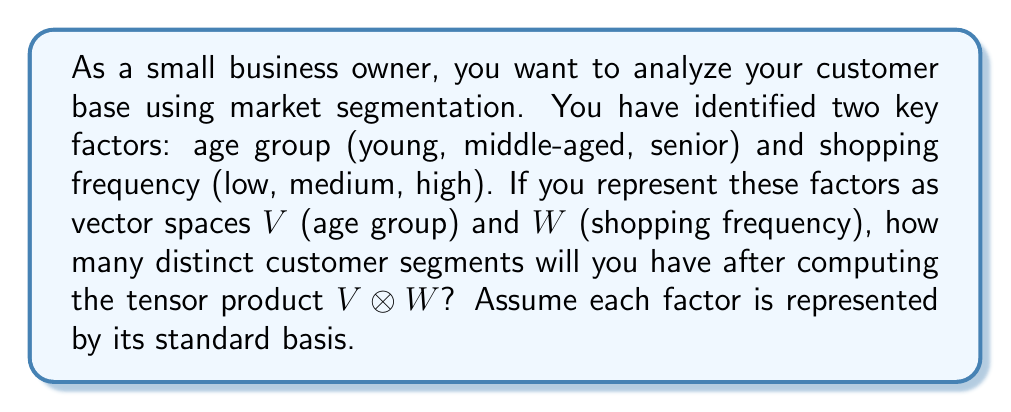Help me with this question. To solve this problem, we'll follow these steps:

1) First, let's identify the dimensions of our vector spaces:
   $\dim(V) = 3$ (young, middle-aged, senior)
   $\dim(W) = 3$ (low, medium, high)

2) The tensor product $V \otimes W$ creates a new vector space that represents all possible combinations of the basis vectors from $V$ and $W$.

3) The dimension of the tensor product space is given by:
   $$\dim(V \otimes W) = \dim(V) \cdot \dim(W)$$

4) Substituting our values:
   $$\dim(V \otimes W) = 3 \cdot 3 = 9$$

5) Each dimension in this new space represents a distinct customer segment. For example:
   - young ⊗ low frequency
   - young ⊗ medium frequency
   - young ⊗ high frequency
   - middle-aged ⊗ low frequency
   ...and so on.

6) Therefore, the number of distinct customer segments is equal to the dimension of the tensor product space, which is 9.

This decomposition allows you, as a business owner, to analyze and target 9 different customer segments based on the combination of age group and shopping frequency.
Answer: 9 distinct customer segments 